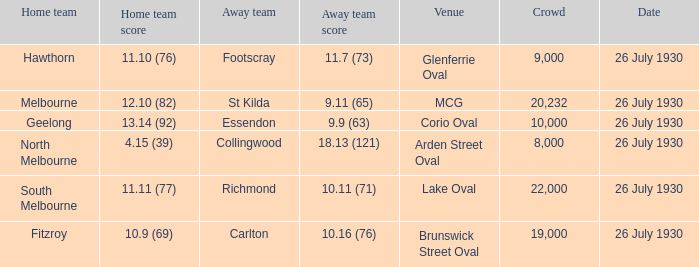When was Fitzroy the home team? 26 July 1930. 